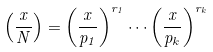Convert formula to latex. <formula><loc_0><loc_0><loc_500><loc_500>\left ( \frac { x } { N } \right ) = \left ( \frac { x } { p _ { 1 } } \right ) ^ { r _ { 1 } } \cdots \left ( \frac { x } { p _ { k } } \right ) ^ { r _ { k } }</formula> 